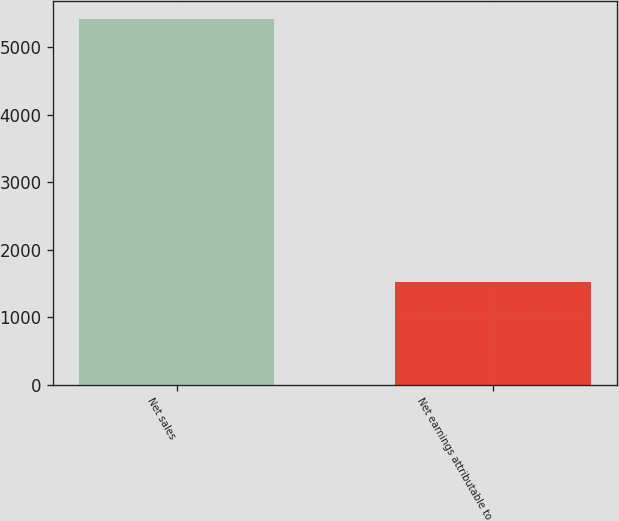Convert chart. <chart><loc_0><loc_0><loc_500><loc_500><bar_chart><fcel>Net sales<fcel>Net earnings attributable to<nl><fcel>5407.8<fcel>1519.2<nl></chart> 